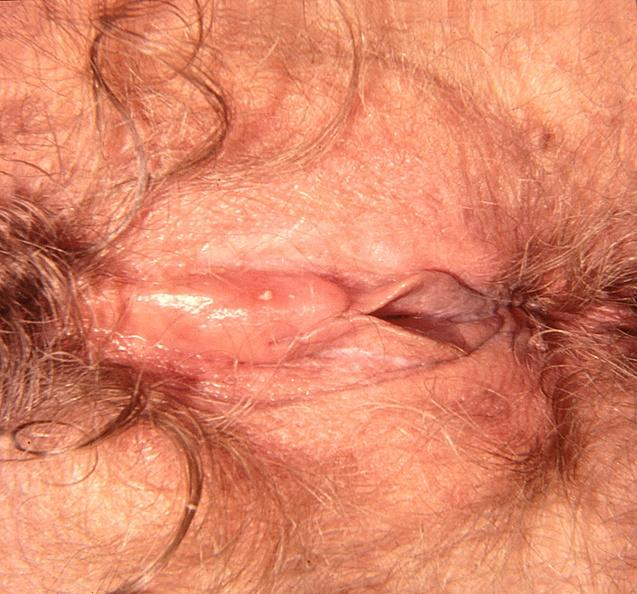what does this image show?
Answer the question using a single word or phrase. Vaginal herpes 